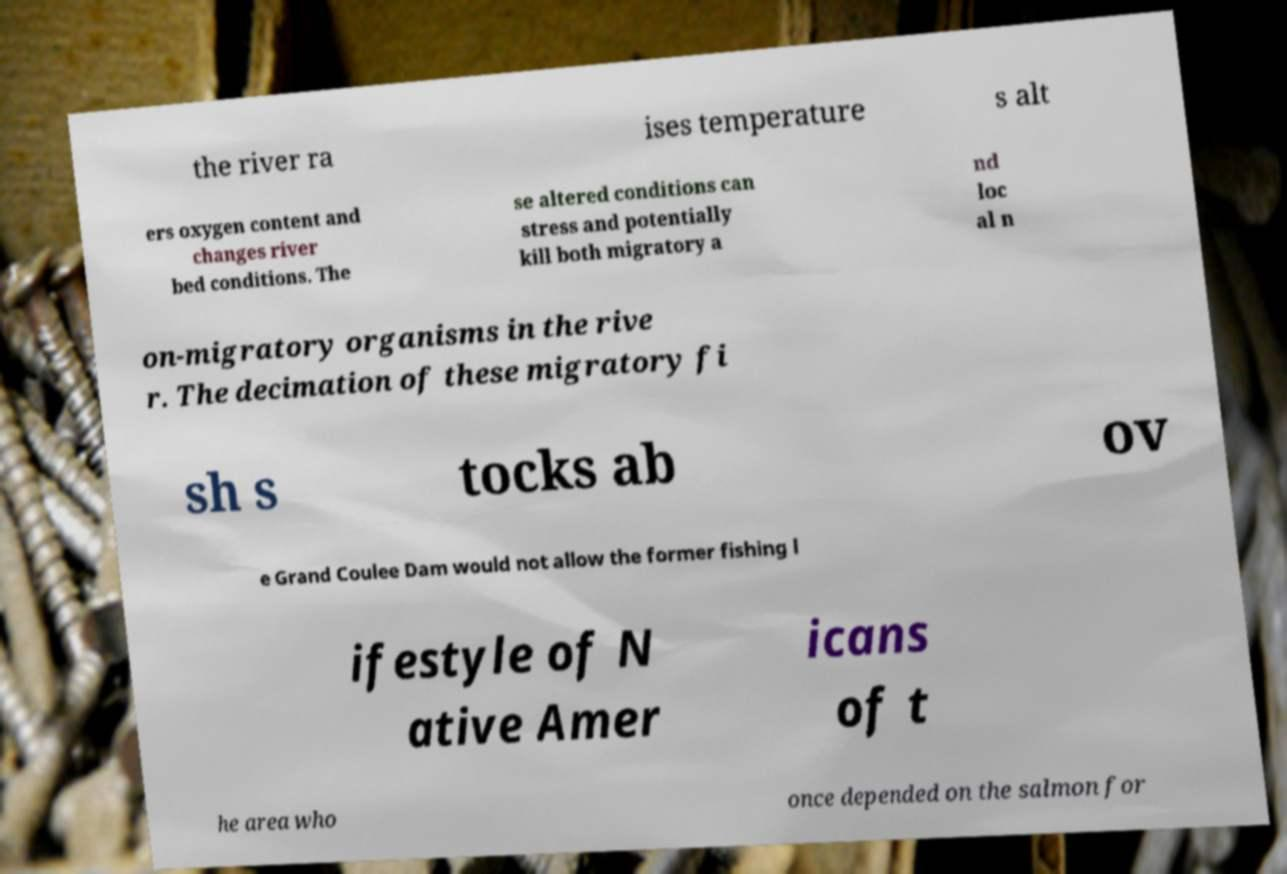There's text embedded in this image that I need extracted. Can you transcribe it verbatim? the river ra ises temperature s alt ers oxygen content and changes river bed conditions. The se altered conditions can stress and potentially kill both migratory a nd loc al n on-migratory organisms in the rive r. The decimation of these migratory fi sh s tocks ab ov e Grand Coulee Dam would not allow the former fishing l ifestyle of N ative Amer icans of t he area who once depended on the salmon for 